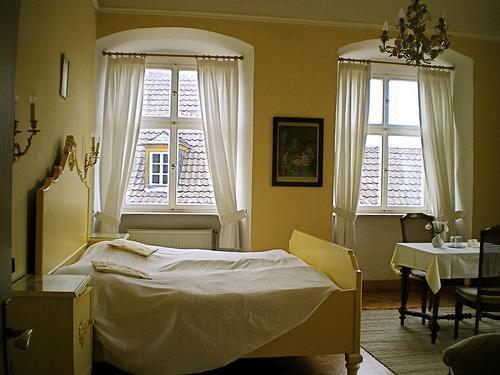How many beds are in the photo?
Give a very brief answer. 1. How many windows are behind the bed?
Give a very brief answer. 1. 